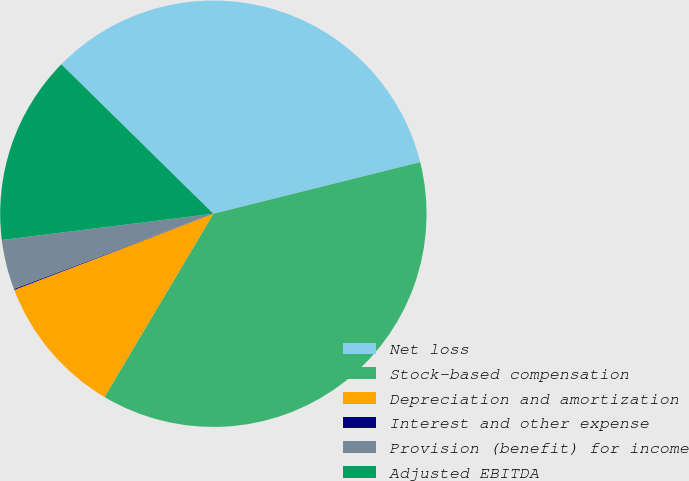Convert chart to OTSL. <chart><loc_0><loc_0><loc_500><loc_500><pie_chart><fcel>Net loss<fcel>Stock-based compensation<fcel>Depreciation and amortization<fcel>Interest and other expense<fcel>Provision (benefit) for income<fcel>Adjusted EBITDA<nl><fcel>33.75%<fcel>37.43%<fcel>10.65%<fcel>0.08%<fcel>3.77%<fcel>14.33%<nl></chart> 